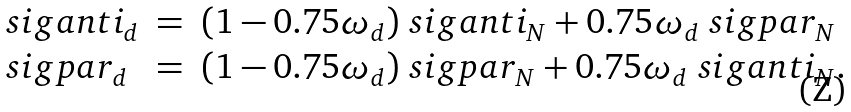<formula> <loc_0><loc_0><loc_500><loc_500>\begin{array} { l c l } \ s i g a n t i _ { d } & = & ( 1 - 0 . 7 5 \omega _ { d } ) \ s i g a n t i _ { N } + 0 . 7 5 \omega _ { d } \ s i g p a r _ { N } \\ \ s i g p a r _ { d } & = & ( 1 - 0 . 7 5 \omega _ { d } ) \ s i g p a r _ { N } + 0 . 7 5 \omega _ { d } \ s i g a n t i _ { N } . \end{array}</formula> 